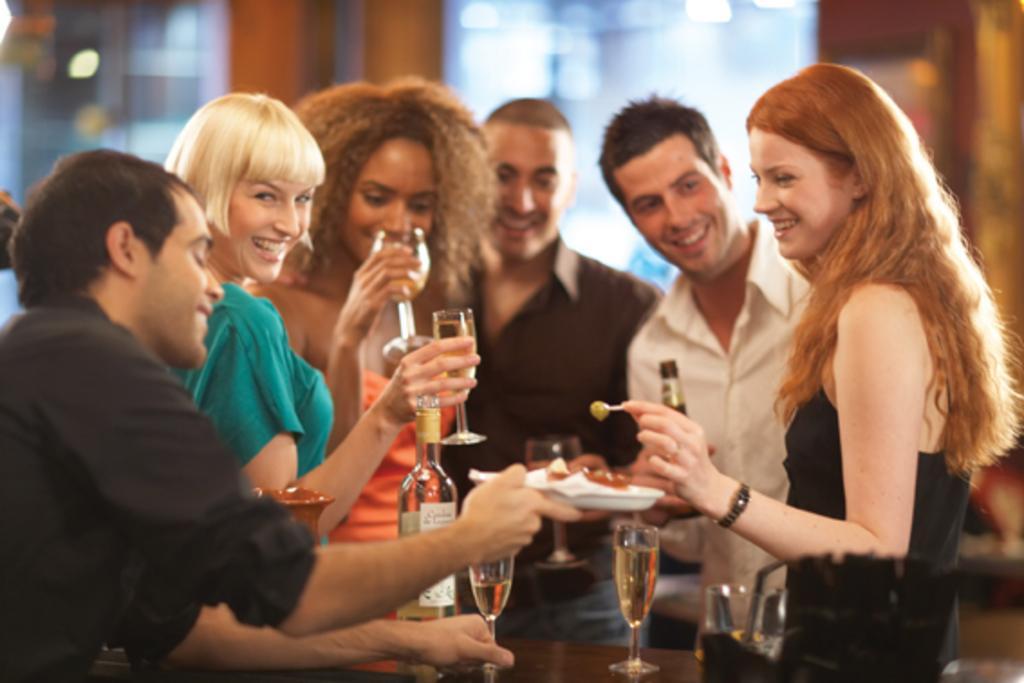Can you describe this image briefly? In this image, we can see a group of people are smiling and holding some objects. In the background of the image, we can see the blur view. 